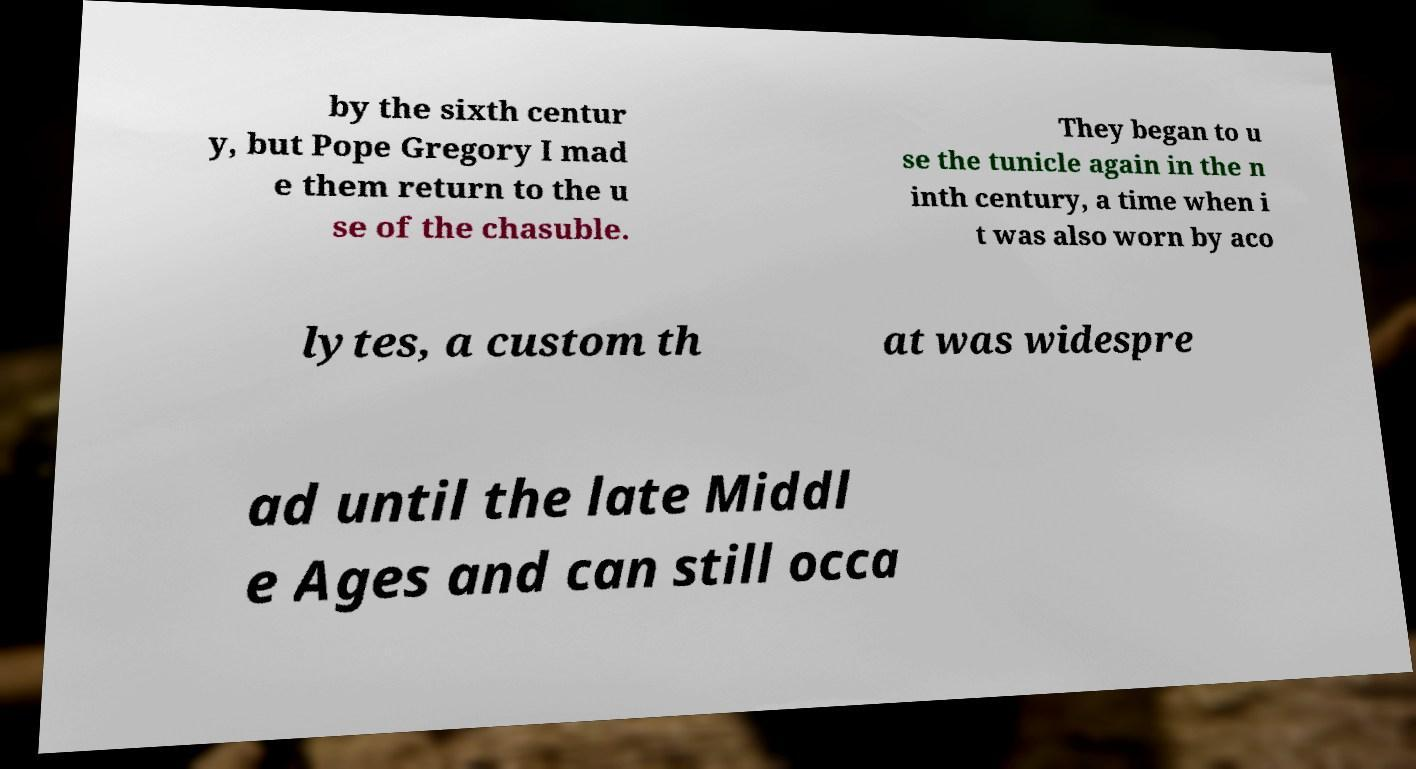There's text embedded in this image that I need extracted. Can you transcribe it verbatim? by the sixth centur y, but Pope Gregory I mad e them return to the u se of the chasuble. They began to u se the tunicle again in the n inth century, a time when i t was also worn by aco lytes, a custom th at was widespre ad until the late Middl e Ages and can still occa 